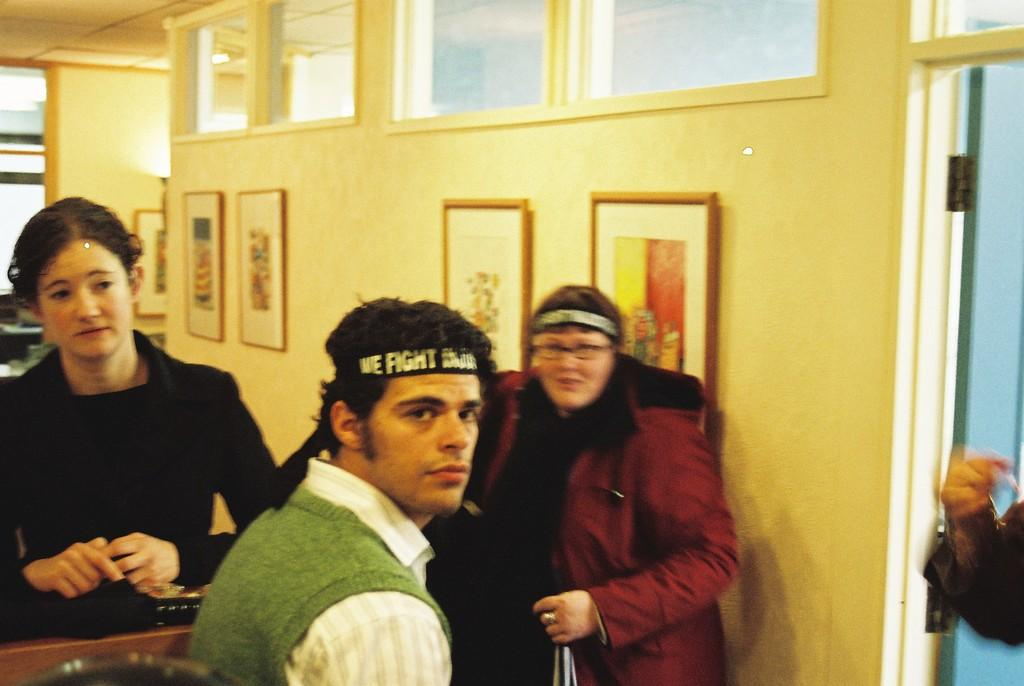How many people are present in the image? There are three persons in the image. What can be seen on the wall in the background? There are photo frames attached to the wall in the background. Can you describe a specific part of a person's body visible in the image? A hand of a person is visible in the right corner of the image. What type of knee injury is the robin suffering from in the image? There is no robin present in the image, and therefore no information about any knee injuries. 